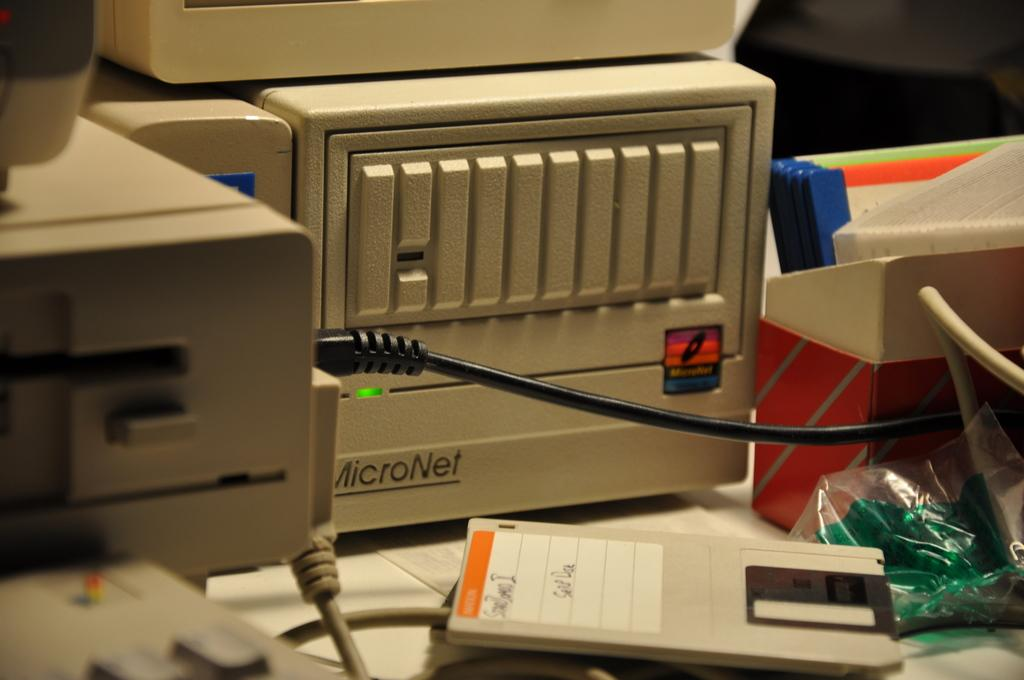<image>
Write a terse but informative summary of the picture. A piece of equipment is made by a company known as MicroNet. 